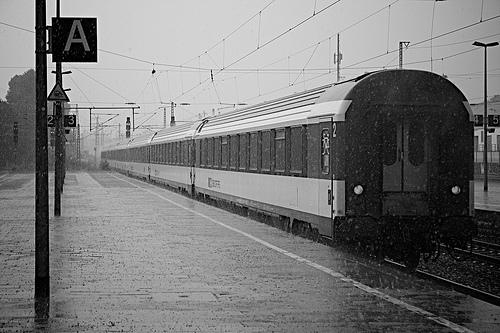Question: who rides the train?
Choices:
A. Passengers.
B. Men and women.
C. Conductor.
D. Men going to work.
Answer with the letter. Answer: A Question: how is the weather?
Choices:
A. Sunny.
B. Cloudy.
C. Snowy.
D. It's rainy.
Answer with the letter. Answer: D 